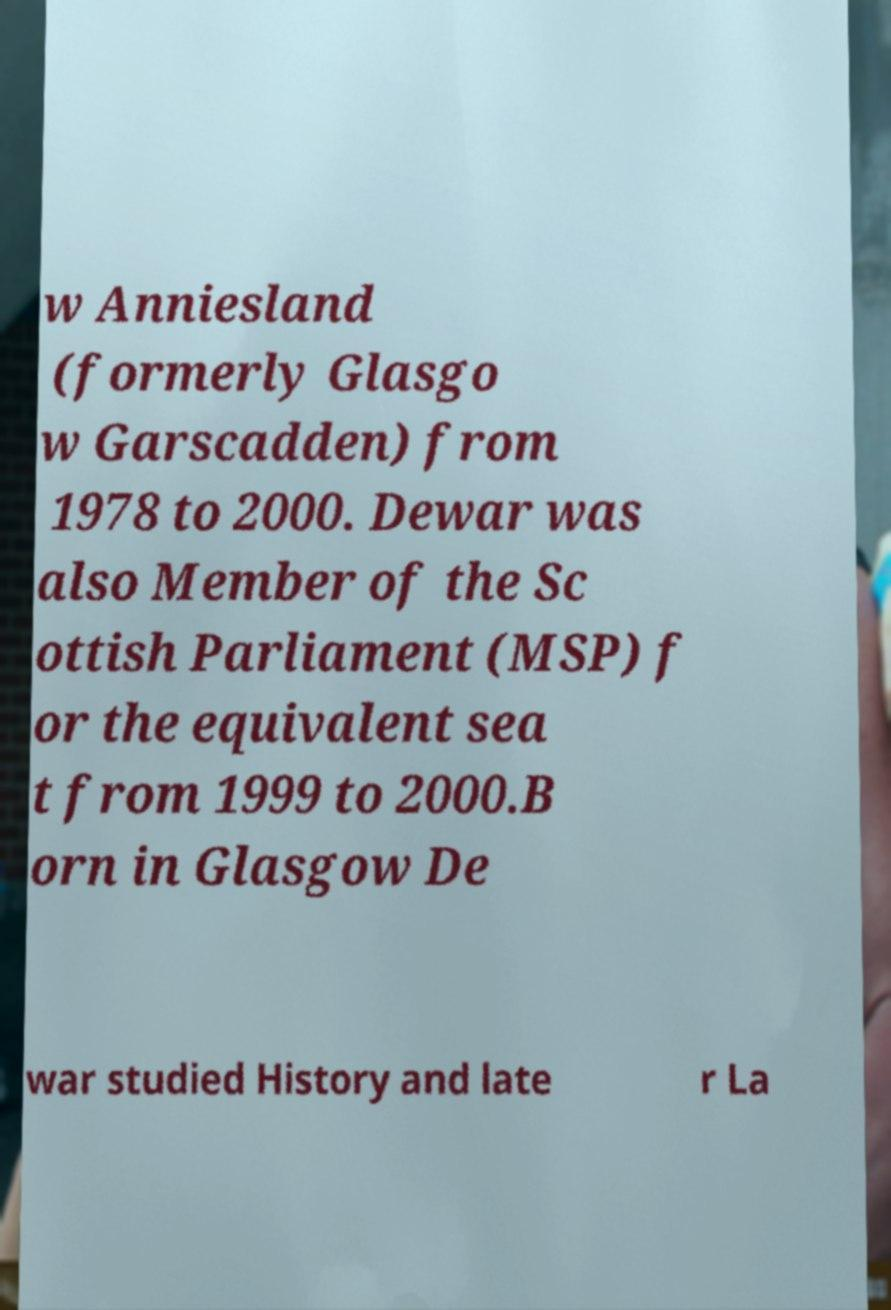For documentation purposes, I need the text within this image transcribed. Could you provide that? w Anniesland (formerly Glasgo w Garscadden) from 1978 to 2000. Dewar was also Member of the Sc ottish Parliament (MSP) f or the equivalent sea t from 1999 to 2000.B orn in Glasgow De war studied History and late r La 